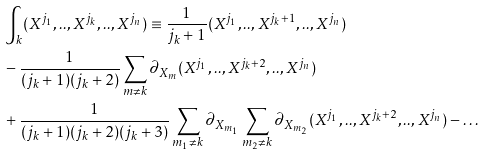<formula> <loc_0><loc_0><loc_500><loc_500>& \int _ { k } ( X ^ { j _ { 1 } } , . . , X ^ { j _ { k } } , . . , X ^ { j _ { n } } ) \equiv \frac { 1 } { j _ { k } + 1 } ( X ^ { j _ { 1 } } , . . , X ^ { j _ { k } + 1 } , . . , X ^ { j _ { n } } ) \\ & - \frac { 1 } { ( j _ { k } + 1 ) ( j _ { k } + 2 ) } \sum _ { m \neq k } \partial _ { X _ { m } } ( X ^ { j _ { 1 } } , . . , X ^ { j _ { k } + 2 } , . . , X ^ { j _ { n } } ) \\ & + \frac { 1 } { ( j _ { k } + 1 ) ( j _ { k } + 2 ) ( j _ { k } + 3 ) } \sum _ { m _ { 1 } \neq k } \partial _ { X _ { m _ { 1 } } } \sum _ { m _ { 2 } \neq k } \partial _ { X _ { m _ { 2 } } } ( X ^ { j _ { 1 } } , . . , X ^ { j _ { k } + 2 } , . . , X ^ { j _ { n } } ) - \dots</formula> 